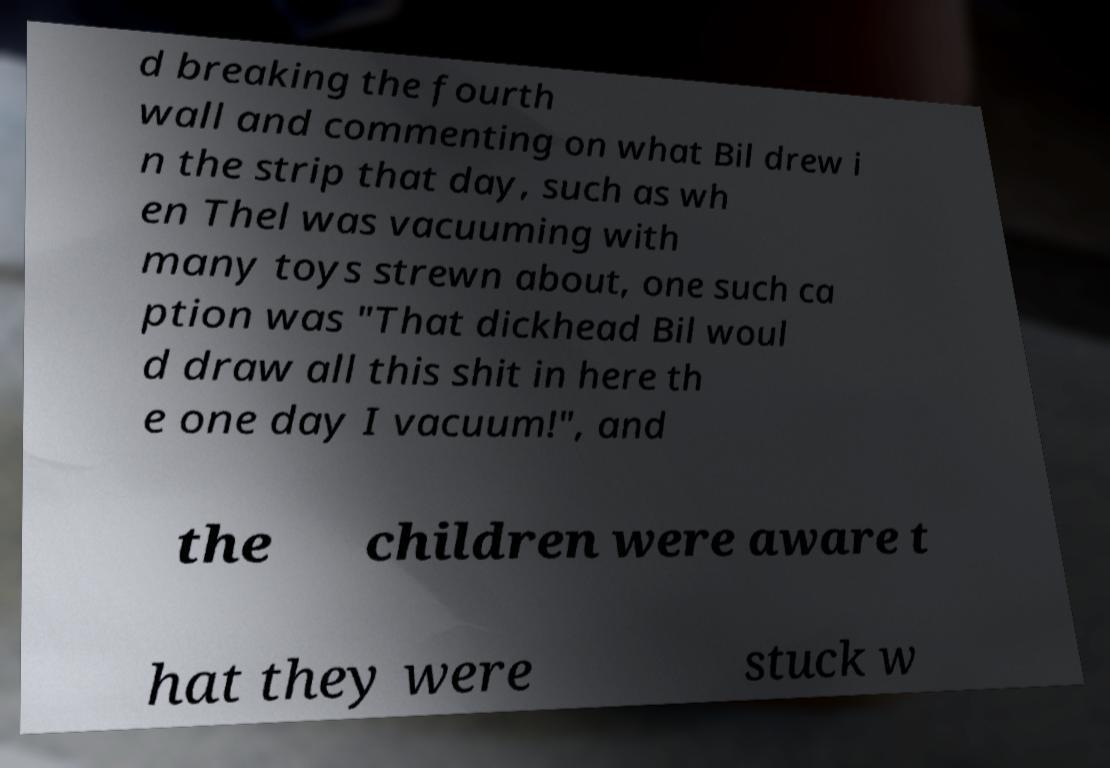Could you extract and type out the text from this image? d breaking the fourth wall and commenting on what Bil drew i n the strip that day, such as wh en Thel was vacuuming with many toys strewn about, one such ca ption was "That dickhead Bil woul d draw all this shit in here th e one day I vacuum!", and the children were aware t hat they were stuck w 